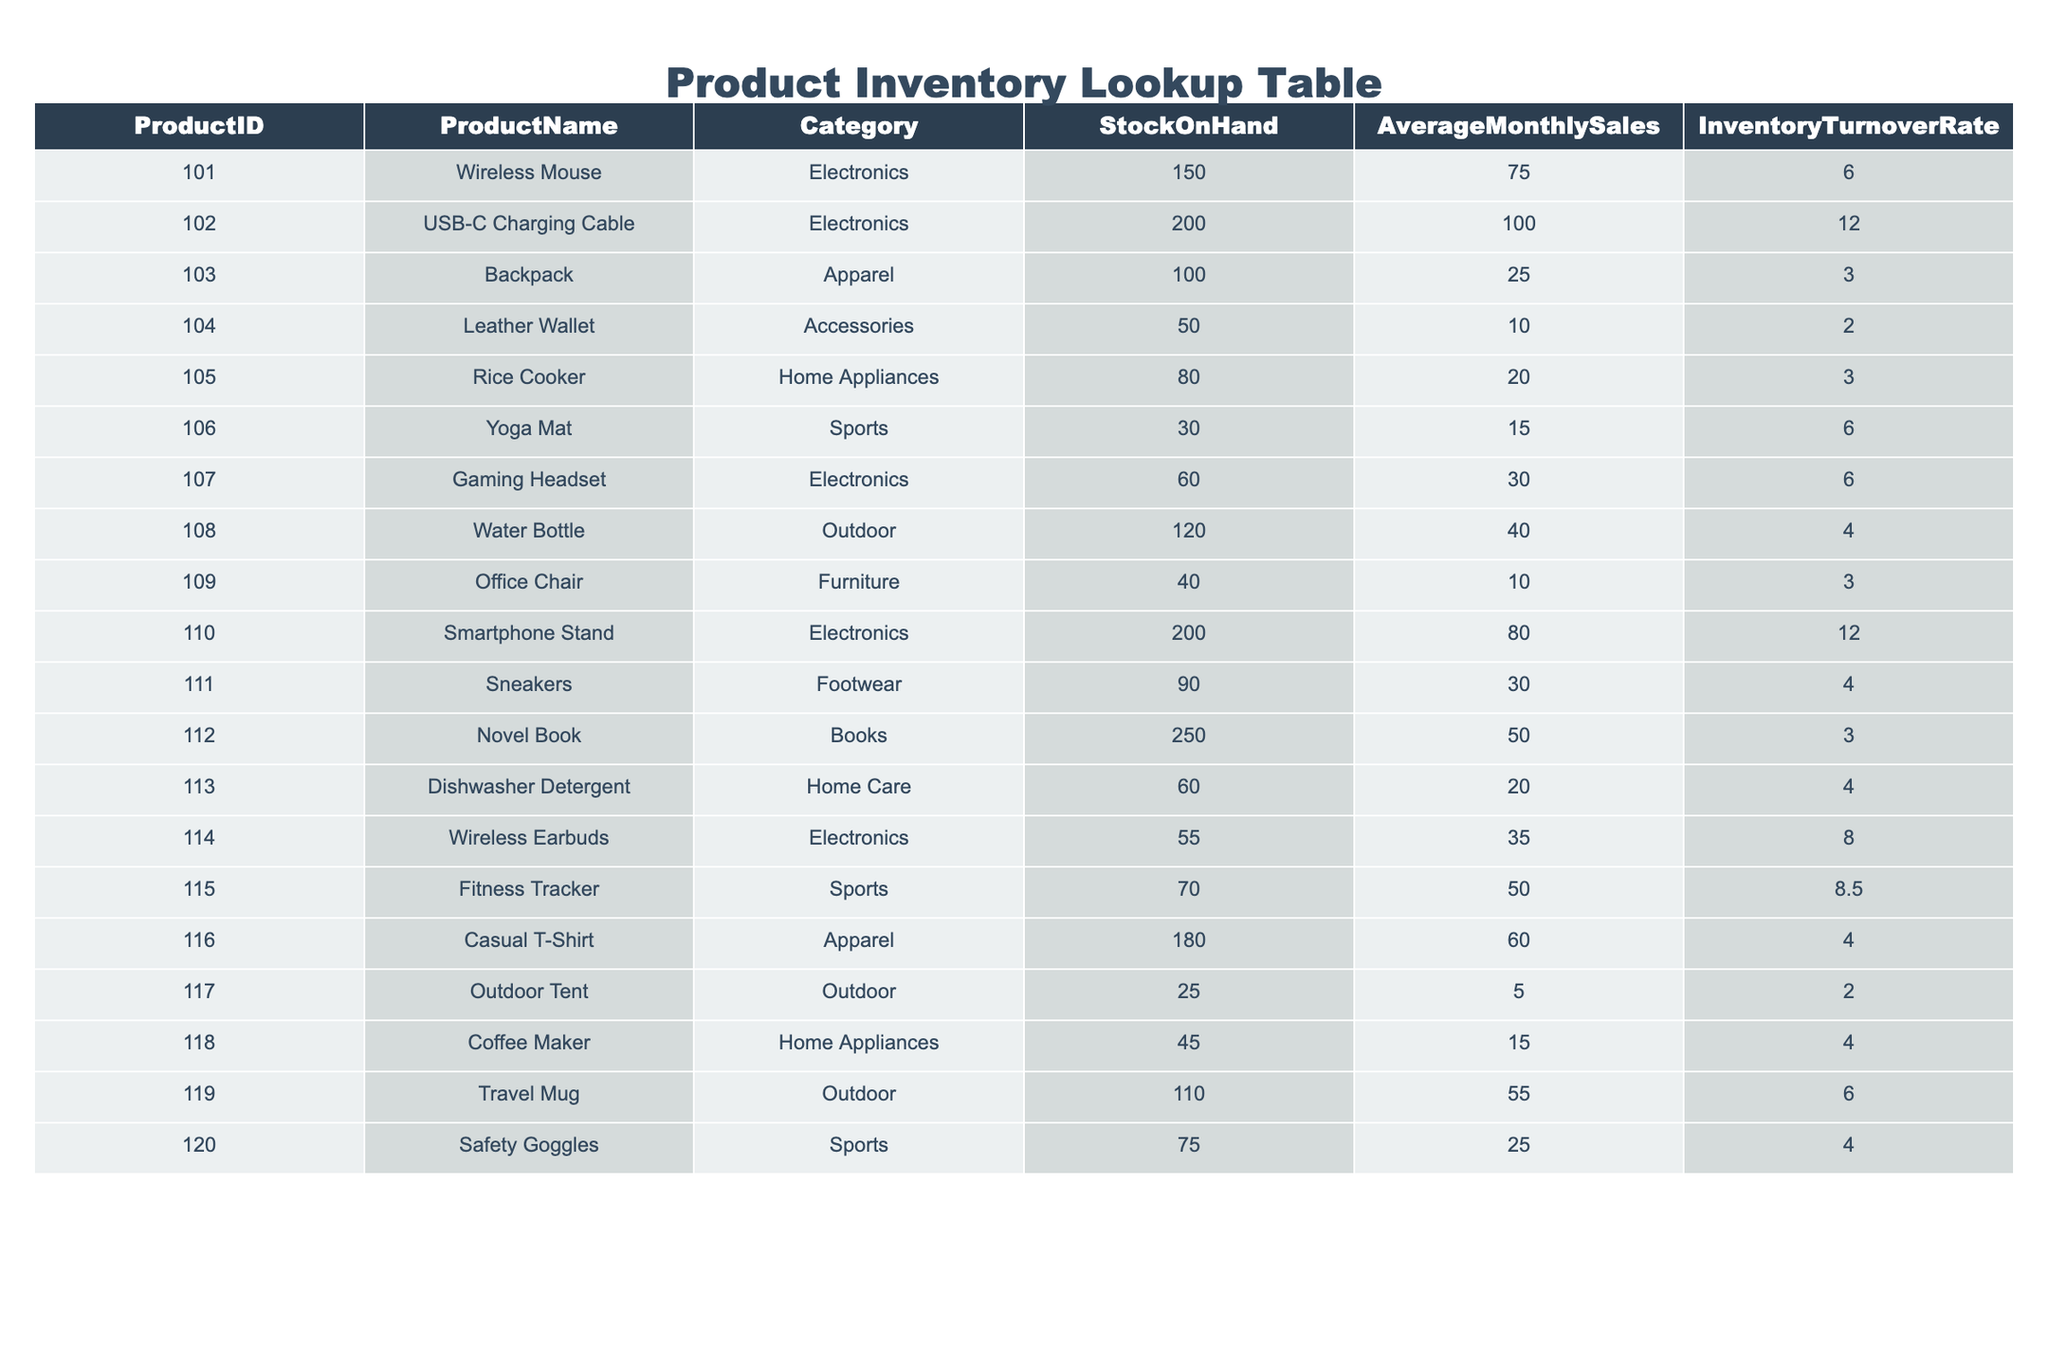What is the Inventory Turnover Rate for the Wireless Mouse? The Inventory Turnover Rate for the Wireless Mouse (Product ID 101) can be found in the table under the corresponding column, which shows the rate as 6.0.
Answer: 6.0 Which product has the highest Inventory Turnover Rate? To find the highest Inventory Turnover Rate, I look through the column and see that the USB-C Charging Cable (Product ID 102) and the Smartphone Stand (Product ID 110) both have the highest rate of 12.0.
Answer: USB-C Charging Cable and Smartphone Stand How many products have an Inventory Turnover Rate greater than 6? I can see in the table that the Wireless Mouse, USB-C Charging Cable, Gaming Headset, Wireless Earbuds, and Fitness Tracker all have an Inventory Turnover Rate greater than 6. In total, there are five such products.
Answer: 5 What is the average Inventory Turnover Rate for products in the Sports category? First, I identify the products in the Sports category: Yoga Mat, Fitness Tracker, and Safety Goggles. Their turnover rates are 6.0, 8.5, and 4.0, respectively. I calculate the average: (6.0 + 8.5 + 4.0) / 3 = 6.17.
Answer: 6.17 Does the Leather Wallet have a higher Inventory Turnover Rate than the average for the Apparel category? The Leather Wallet has a turnover rate of 2.0. The average for Apparel (Casual T-Shirt and Backpack) is calculated as (3.0 + 4.0) / 2 = 3.5. Since 2.0 is less than 3.5, the answer is no.
Answer: No Which product category has the lowest average Inventory Turnover Rate? I examine the Inventory Turnover Rates by category: Electronics has 6.0, Apparel has 3.5, Accessories has 2.0, Home Appliances has 3.0, Sports has 6.17, Outdoor has 4.0, and Furniture has 3.0. The Accessories category has the lowest average of 2.0.
Answer: Accessories What is the total Stock On Hand for all products in the Electronics category? I add the Stock On Hand values for products in the Electronics category: Wireless Mouse (150) + USB-C Charging Cable (200) + Gaming Headset (60) + Smartphone Stand (200) + Wireless Earbuds (55), totaling 150 + 200 + 60 + 200 + 55 = 665.
Answer: 665 Which product has the lowest Stock On Hand? Looking through the Stock On Hand column, the product with the lowest amount is the Outdoor Tent with 25 units listed.
Answer: Outdoor Tent What is the ratio of Average Monthly Sales to Stock On Hand for the Backpack? For the Backpack, Stock On Hand is 100 and Average Monthly Sales is 25. The ratio is calculated as: 25 / 100 = 0.25.
Answer: 0.25 